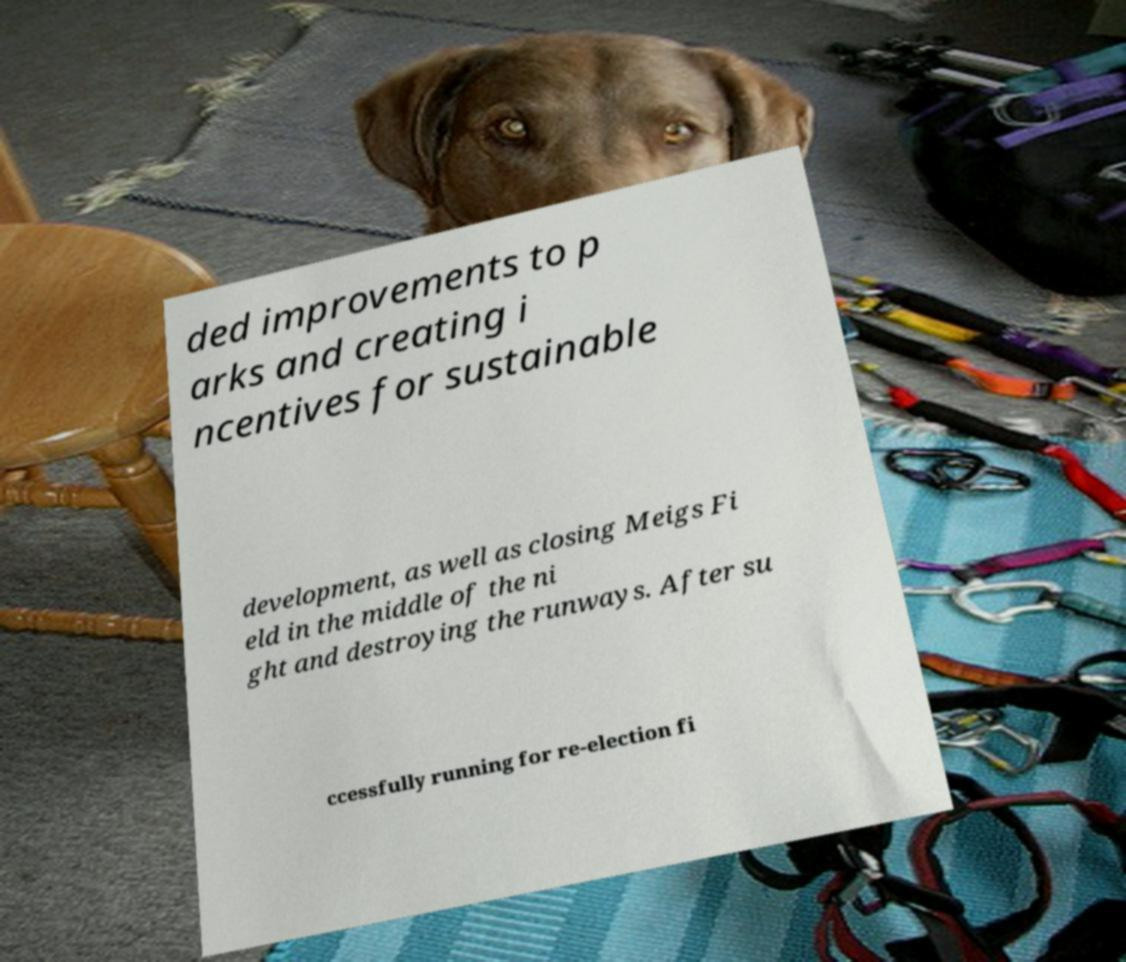I need the written content from this picture converted into text. Can you do that? ded improvements to p arks and creating i ncentives for sustainable development, as well as closing Meigs Fi eld in the middle of the ni ght and destroying the runways. After su ccessfully running for re-election fi 